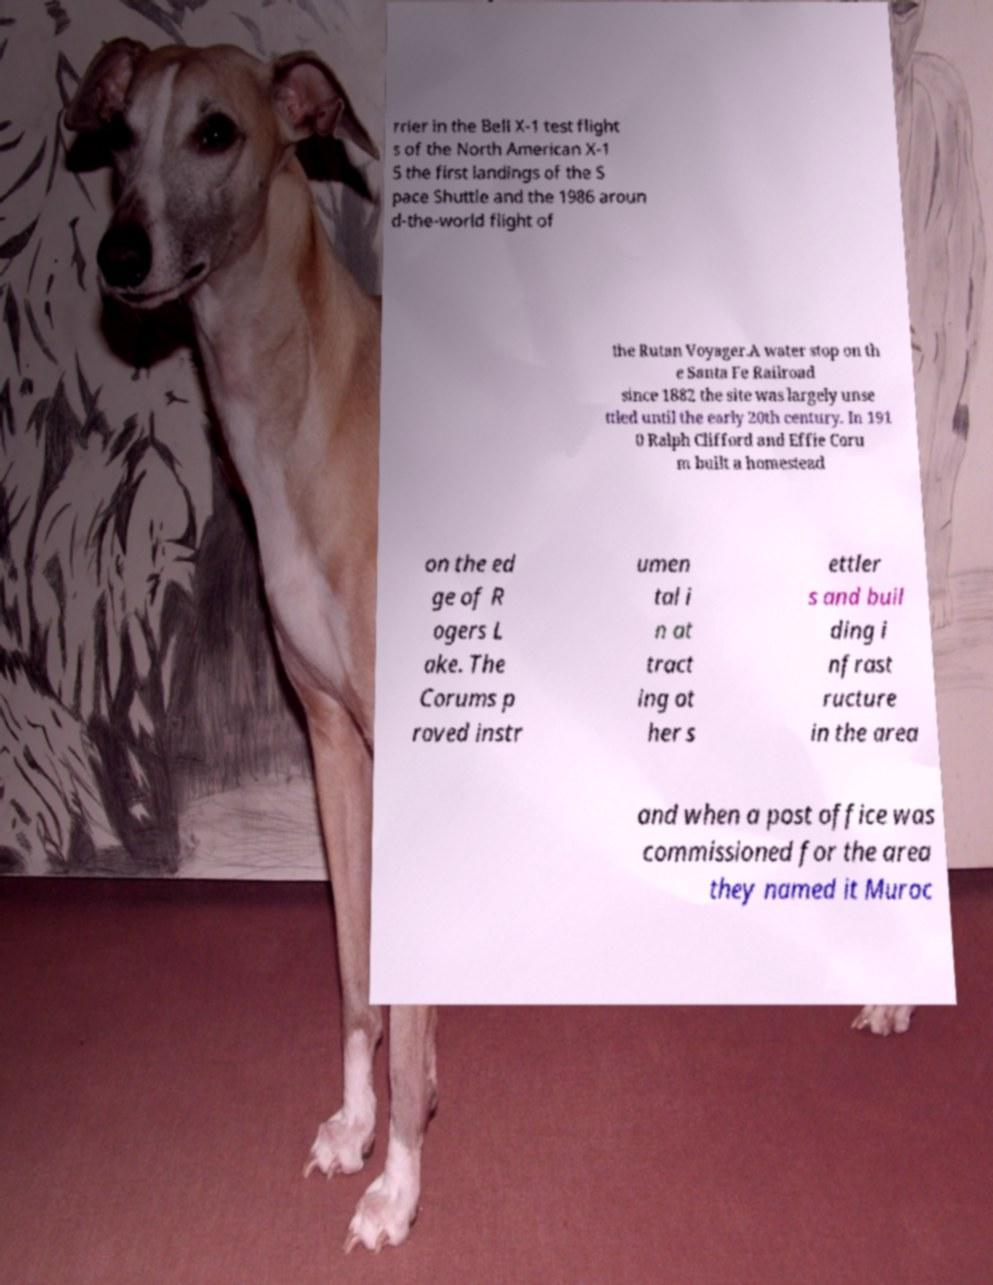Can you read and provide the text displayed in the image?This photo seems to have some interesting text. Can you extract and type it out for me? rrier in the Bell X-1 test flight s of the North American X-1 5 the first landings of the S pace Shuttle and the 1986 aroun d-the-world flight of the Rutan Voyager.A water stop on th e Santa Fe Railroad since 1882 the site was largely unse ttled until the early 20th century. In 191 0 Ralph Clifford and Effie Coru m built a homestead on the ed ge of R ogers L ake. The Corums p roved instr umen tal i n at tract ing ot her s ettler s and buil ding i nfrast ructure in the area and when a post office was commissioned for the area they named it Muroc 